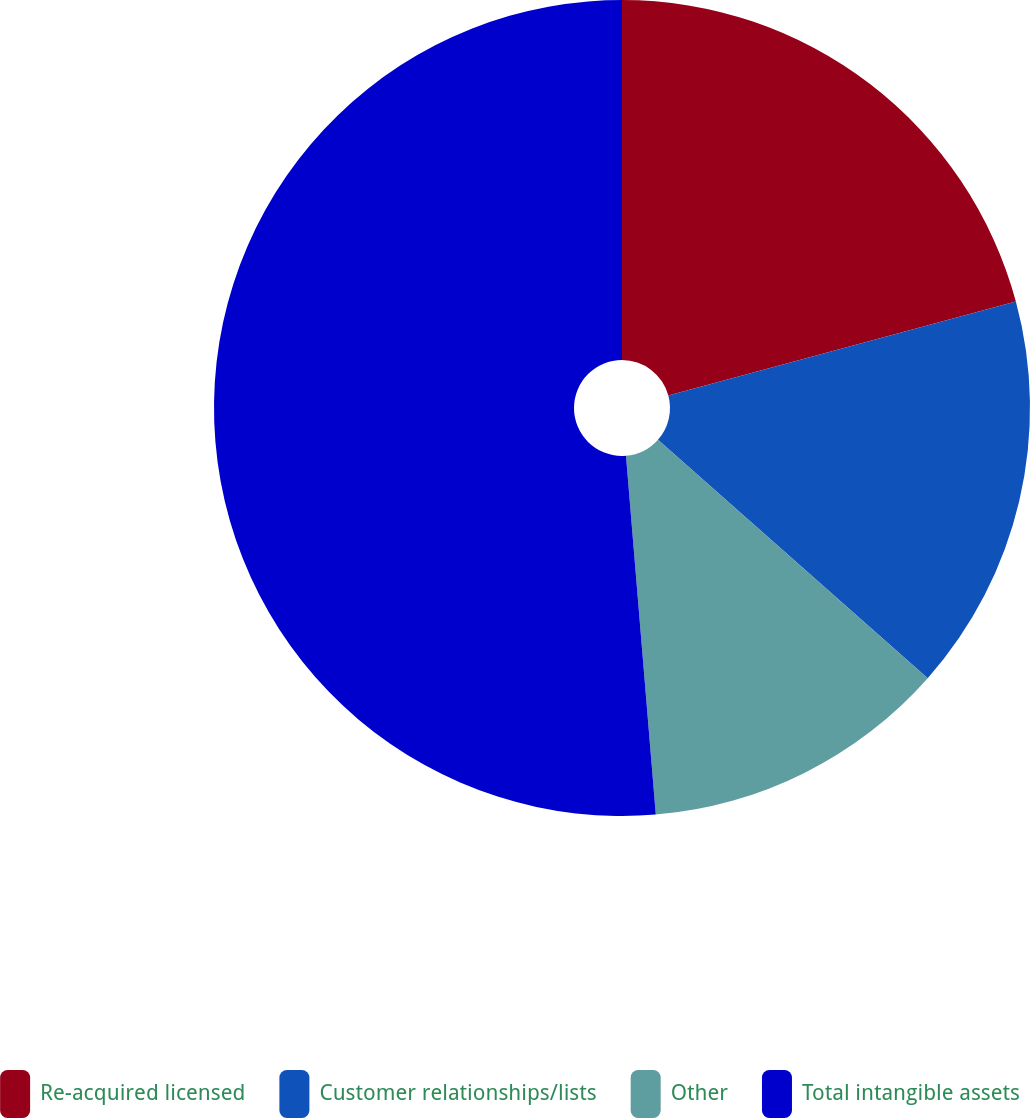Convert chart to OTSL. <chart><loc_0><loc_0><loc_500><loc_500><pie_chart><fcel>Re-acquired licensed<fcel>Customer relationships/lists<fcel>Other<fcel>Total intangible assets<nl><fcel>20.8%<fcel>15.72%<fcel>12.16%<fcel>51.32%<nl></chart> 